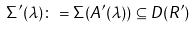<formula> <loc_0><loc_0><loc_500><loc_500>\Sigma ^ { \prime } ( \lambda ) \colon = \Sigma ( A ^ { \prime } ( \lambda ) ) \subseteq D ( R ^ { \prime } )</formula> 